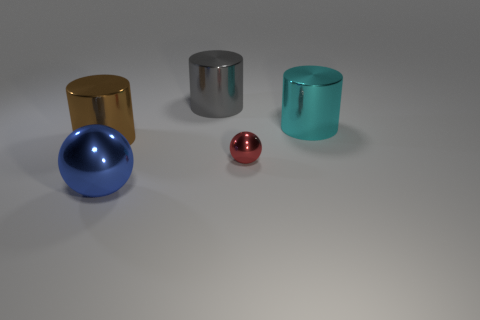Subtract all cyan cylinders. Subtract all yellow cubes. How many cylinders are left? 2 Add 1 small objects. How many objects exist? 6 Subtract all cylinders. How many objects are left? 2 Subtract 1 brown cylinders. How many objects are left? 4 Subtract all large blue shiny objects. Subtract all tiny red balls. How many objects are left? 3 Add 4 gray cylinders. How many gray cylinders are left? 5 Add 4 big metal spheres. How many big metal spheres exist? 5 